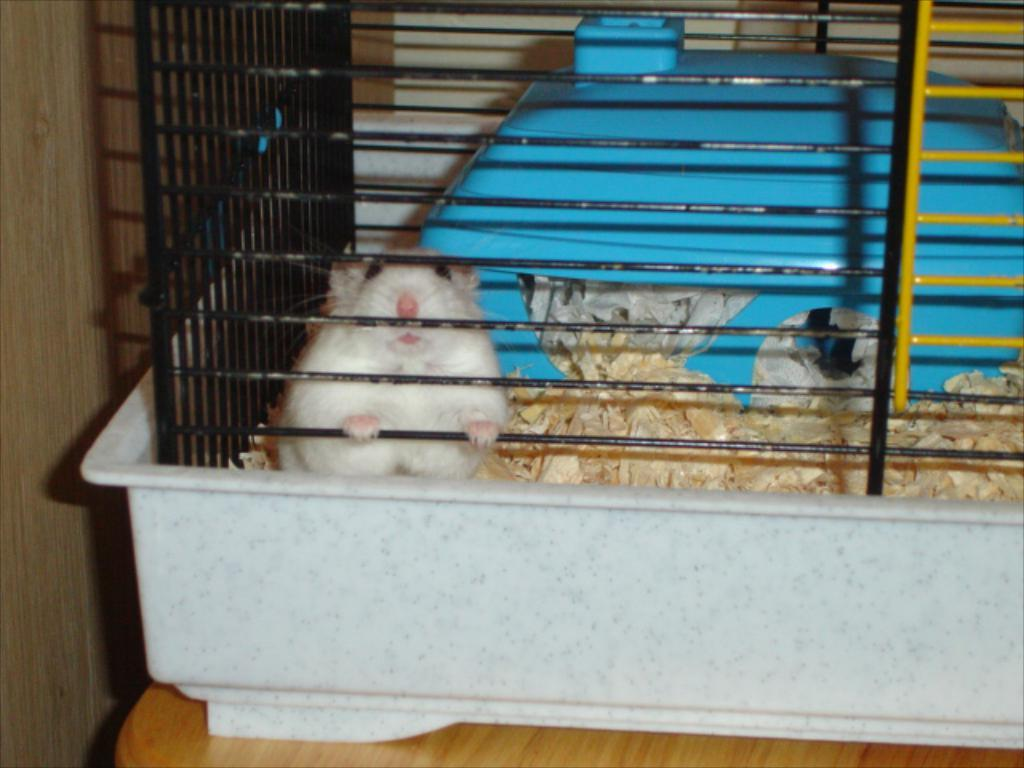What animal is the main subject in the image? There is a white rat in the image. What is the rat doing in the image? The rat is holding a fence. Where is the fence placed in the image? The fence is placed on a table. What else can be seen in the image besides the rat and the fence? There are other objects beside the rat. What color is the object behind the rat? There is a blue color object behind the rat. What hobbies does the creator of the image have? There is no information provided about the creator of the image, so we cannot determine their hobbies. Can you see a hen in the image? No, there is no hen present in the image. 